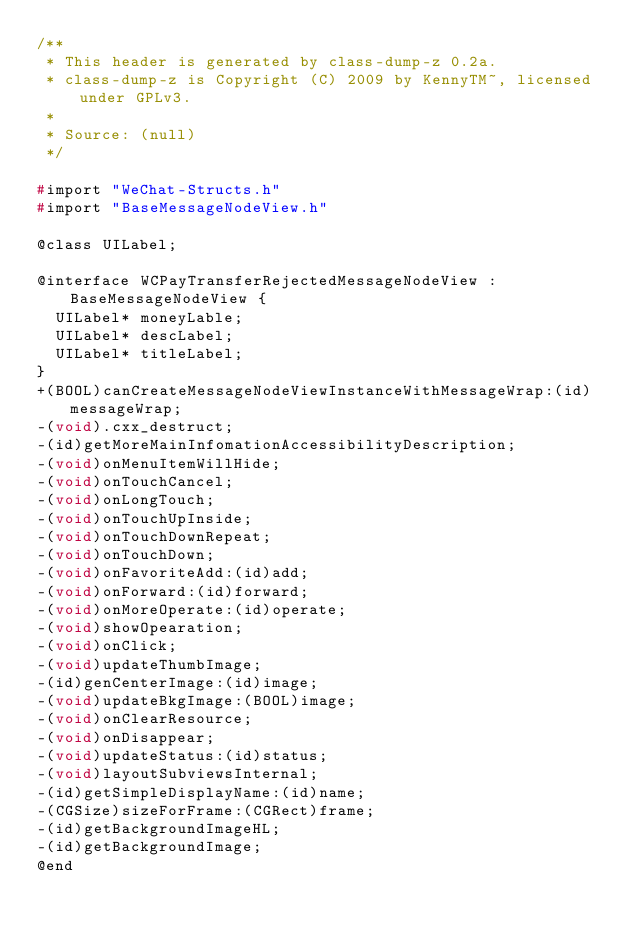Convert code to text. <code><loc_0><loc_0><loc_500><loc_500><_C_>/**
 * This header is generated by class-dump-z 0.2a.
 * class-dump-z is Copyright (C) 2009 by KennyTM~, licensed under GPLv3.
 *
 * Source: (null)
 */

#import "WeChat-Structs.h"
#import "BaseMessageNodeView.h"

@class UILabel;

@interface WCPayTransferRejectedMessageNodeView : BaseMessageNodeView {
	UILabel* moneyLable;
	UILabel* descLabel;
	UILabel* titleLabel;
}
+(BOOL)canCreateMessageNodeViewInstanceWithMessageWrap:(id)messageWrap;
-(void).cxx_destruct;
-(id)getMoreMainInfomationAccessibilityDescription;
-(void)onMenuItemWillHide;
-(void)onTouchCancel;
-(void)onLongTouch;
-(void)onTouchUpInside;
-(void)onTouchDownRepeat;
-(void)onTouchDown;
-(void)onFavoriteAdd:(id)add;
-(void)onForward:(id)forward;
-(void)onMoreOperate:(id)operate;
-(void)showOpearation;
-(void)onClick;
-(void)updateThumbImage;
-(id)genCenterImage:(id)image;
-(void)updateBkgImage:(BOOL)image;
-(void)onClearResource;
-(void)onDisappear;
-(void)updateStatus:(id)status;
-(void)layoutSubviewsInternal;
-(id)getSimpleDisplayName:(id)name;
-(CGSize)sizeForFrame:(CGRect)frame;
-(id)getBackgroundImageHL;
-(id)getBackgroundImage;
@end

</code> 